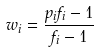Convert formula to latex. <formula><loc_0><loc_0><loc_500><loc_500>w _ { i } = \frac { p _ { i } f _ { i } - 1 } { f _ { i } - 1 }</formula> 